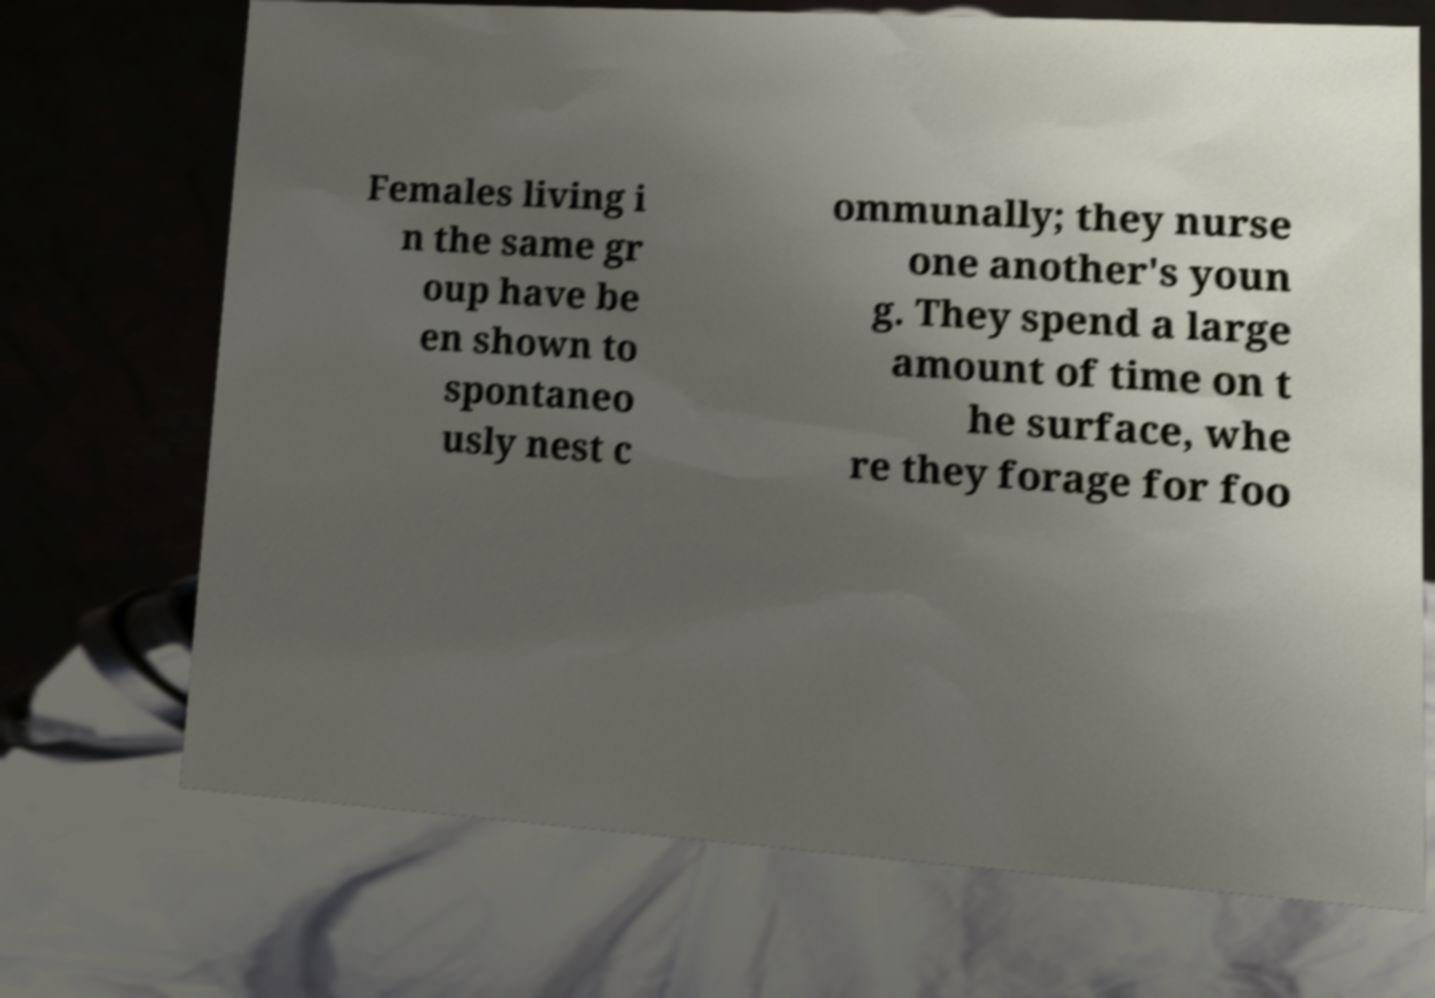Could you assist in decoding the text presented in this image and type it out clearly? Females living i n the same gr oup have be en shown to spontaneo usly nest c ommunally; they nurse one another's youn g. They spend a large amount of time on t he surface, whe re they forage for foo 